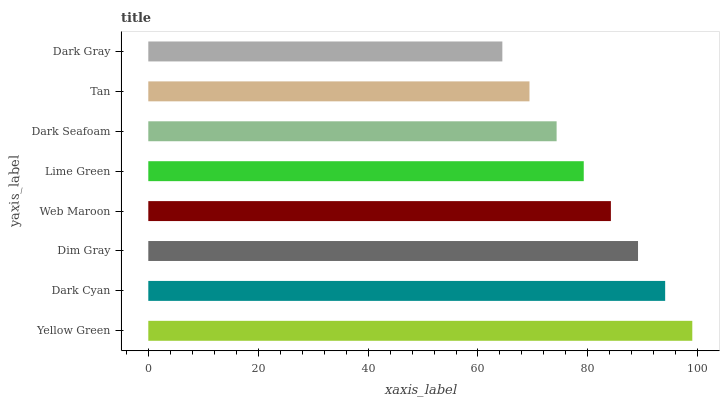Is Dark Gray the minimum?
Answer yes or no. Yes. Is Yellow Green the maximum?
Answer yes or no. Yes. Is Dark Cyan the minimum?
Answer yes or no. No. Is Dark Cyan the maximum?
Answer yes or no. No. Is Yellow Green greater than Dark Cyan?
Answer yes or no. Yes. Is Dark Cyan less than Yellow Green?
Answer yes or no. Yes. Is Dark Cyan greater than Yellow Green?
Answer yes or no. No. Is Yellow Green less than Dark Cyan?
Answer yes or no. No. Is Web Maroon the high median?
Answer yes or no. Yes. Is Lime Green the low median?
Answer yes or no. Yes. Is Dim Gray the high median?
Answer yes or no. No. Is Dark Seafoam the low median?
Answer yes or no. No. 